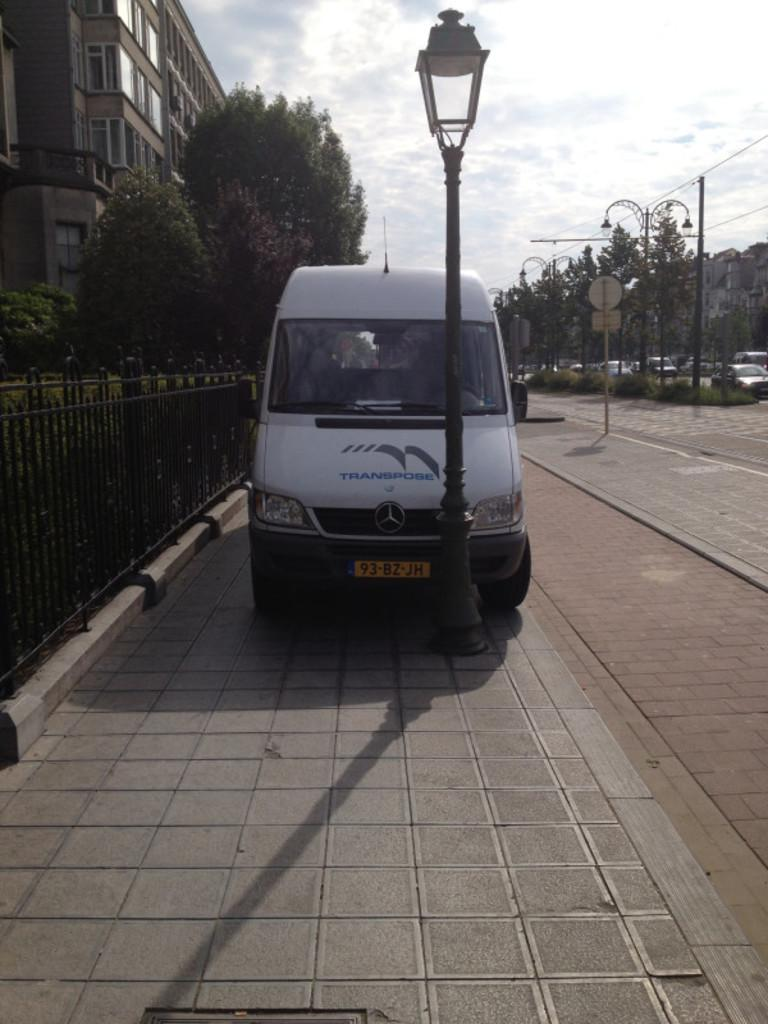<image>
Create a compact narrative representing the image presented. A white van has the word transpose on the hood. 